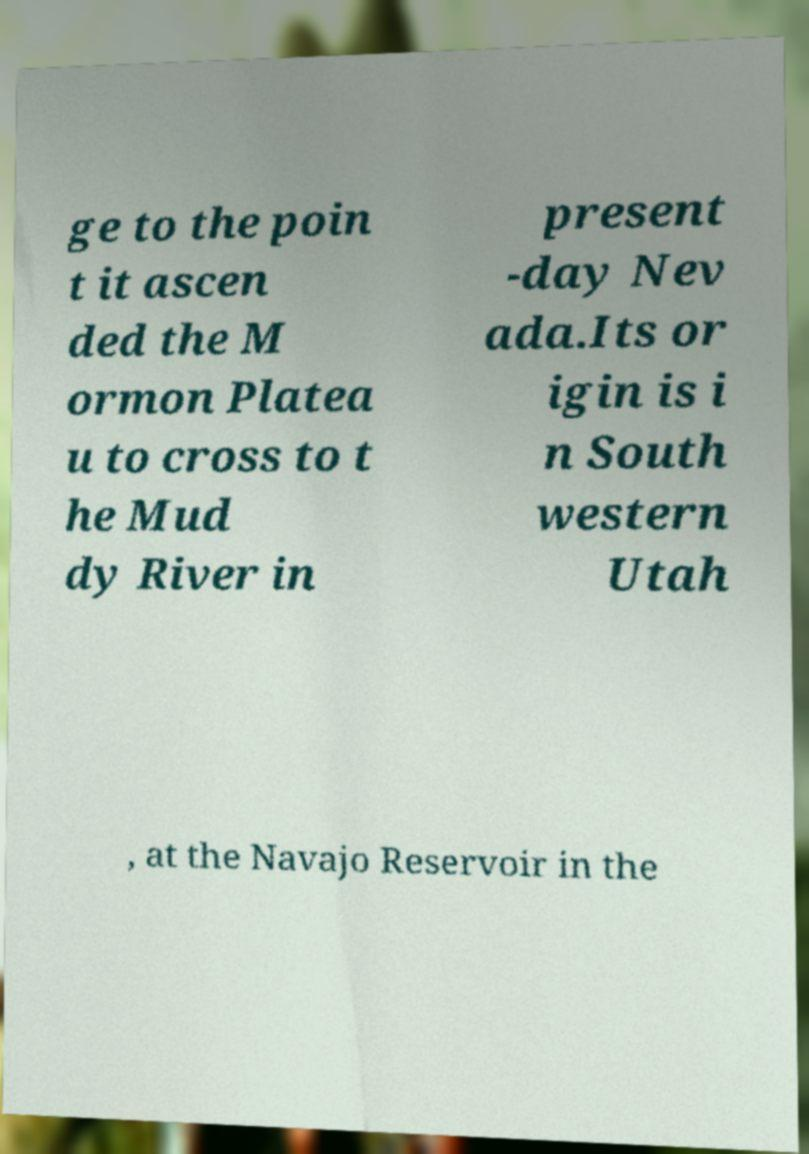What messages or text are displayed in this image? I need them in a readable, typed format. ge to the poin t it ascen ded the M ormon Platea u to cross to t he Mud dy River in present -day Nev ada.Its or igin is i n South western Utah , at the Navajo Reservoir in the 